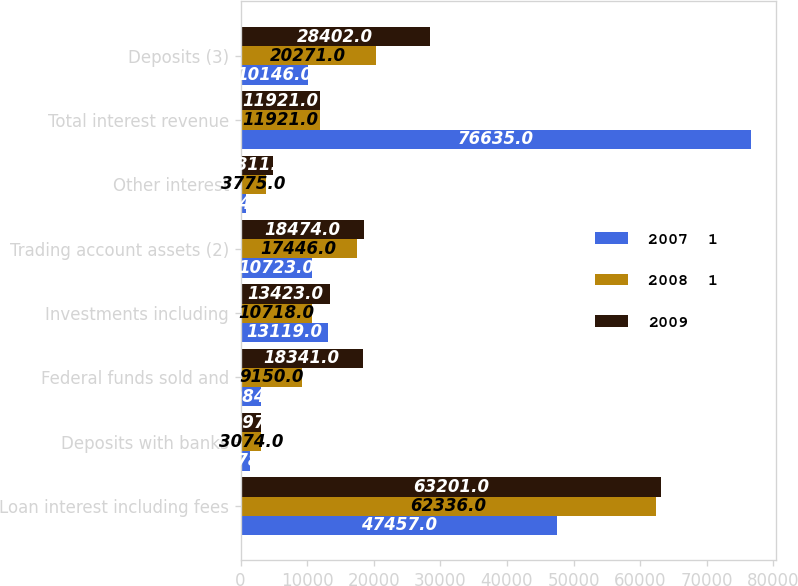<chart> <loc_0><loc_0><loc_500><loc_500><stacked_bar_chart><ecel><fcel>Loan interest including fees<fcel>Deposits with banks<fcel>Federal funds sold and<fcel>Investments including<fcel>Trading account assets (2)<fcel>Other interest<fcel>Total interest revenue<fcel>Deposits (3)<nl><fcel>2007  1<fcel>47457<fcel>1478<fcel>3084<fcel>13119<fcel>10723<fcel>774<fcel>76635<fcel>10146<nl><fcel>2008  1<fcel>62336<fcel>3074<fcel>9150<fcel>10718<fcel>17446<fcel>3775<fcel>11921<fcel>20271<nl><fcel>2009<fcel>63201<fcel>3097<fcel>18341<fcel>13423<fcel>18474<fcel>4811<fcel>11921<fcel>28402<nl></chart> 